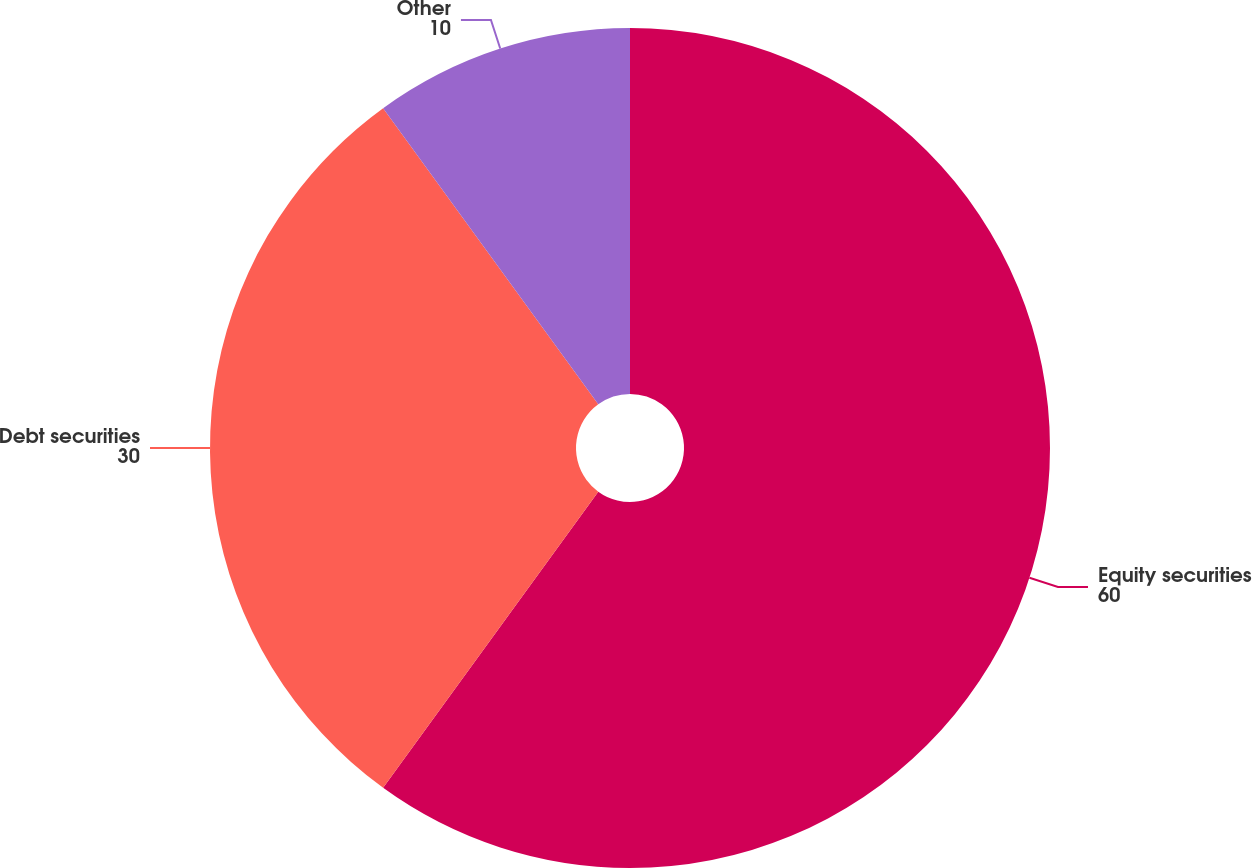<chart> <loc_0><loc_0><loc_500><loc_500><pie_chart><fcel>Equity securities<fcel>Debt securities<fcel>Other<nl><fcel>60.0%<fcel>30.0%<fcel>10.0%<nl></chart> 